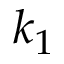<formula> <loc_0><loc_0><loc_500><loc_500>k _ { 1 }</formula> 